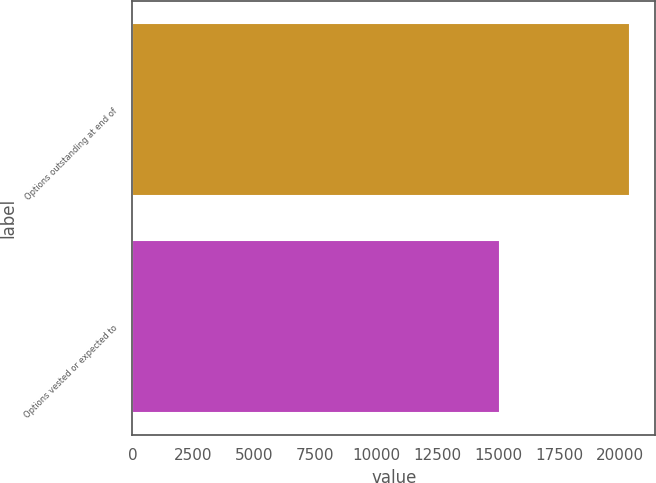Convert chart to OTSL. <chart><loc_0><loc_0><loc_500><loc_500><bar_chart><fcel>Options outstanding at end of<fcel>Options vested or expected to<nl><fcel>20422<fcel>15075<nl></chart> 